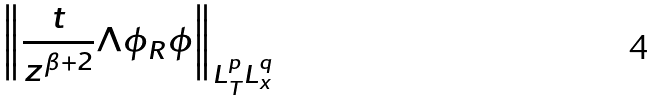Convert formula to latex. <formula><loc_0><loc_0><loc_500><loc_500>\left \| \frac { t } { z ^ { \beta + 2 } } \Lambda \phi _ { R } \phi \right \| _ { L ^ { p } _ { T } L ^ { q } _ { x } }</formula> 